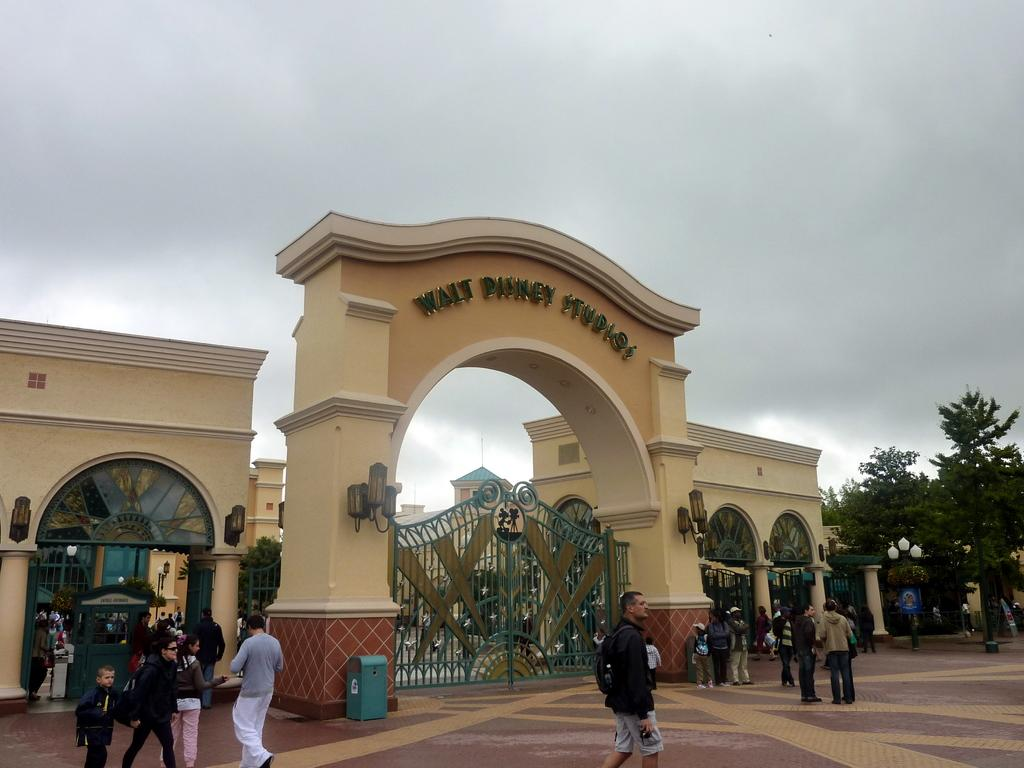<image>
Present a compact description of the photo's key features. the entrance to the Walt Disney Studios and closed gate 